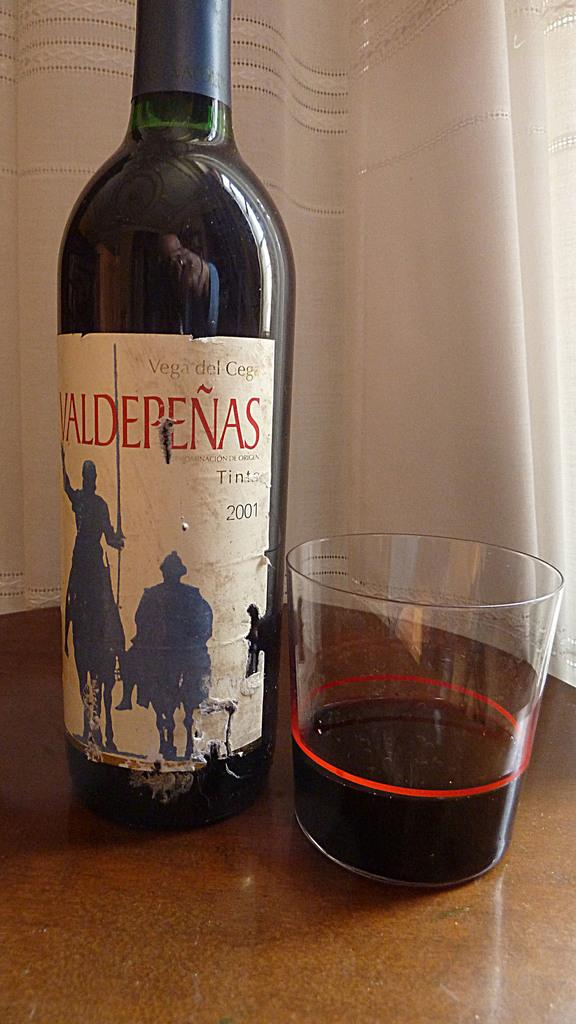What piece of furniture is present in the image? There is a table in the image. What is placed on the table? There is a wine bottle and a glass on the table. What can be seen in the background of the image? There is a curtain in the background of the image. What type of crook is visible in the image? There is no crook present in the image. How does the steam escape from the wine bottle in the image? There is no steam present in the image, as the wine bottle is not open or heated. 